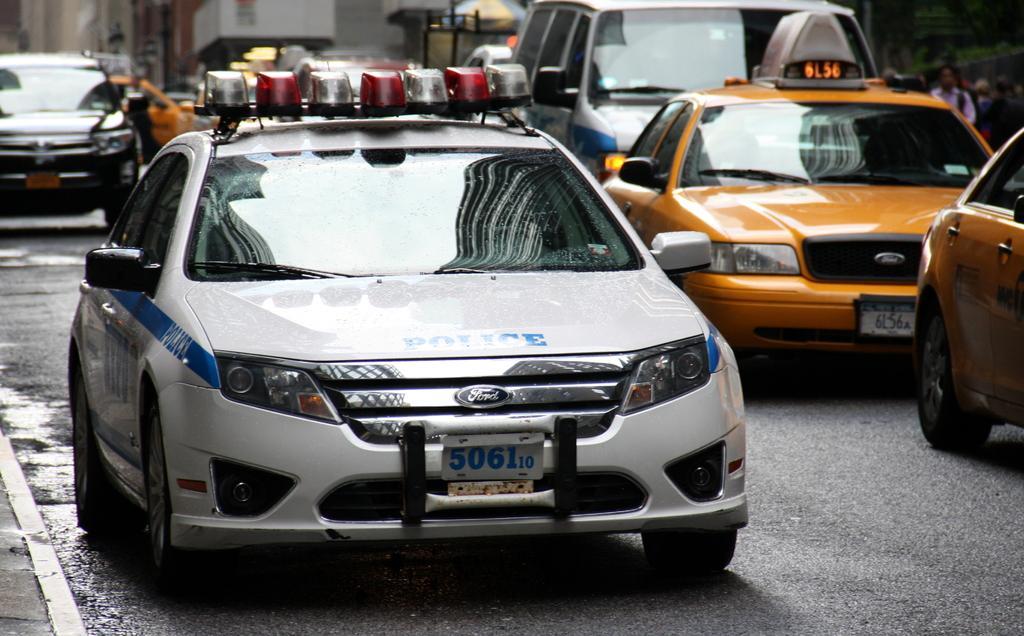In one or two sentences, can you explain what this image depicts? In the background portion of the picture is blur. In this picture we can see vehicles on the road. On the right side we can see people. Far we can see an umbrella. 